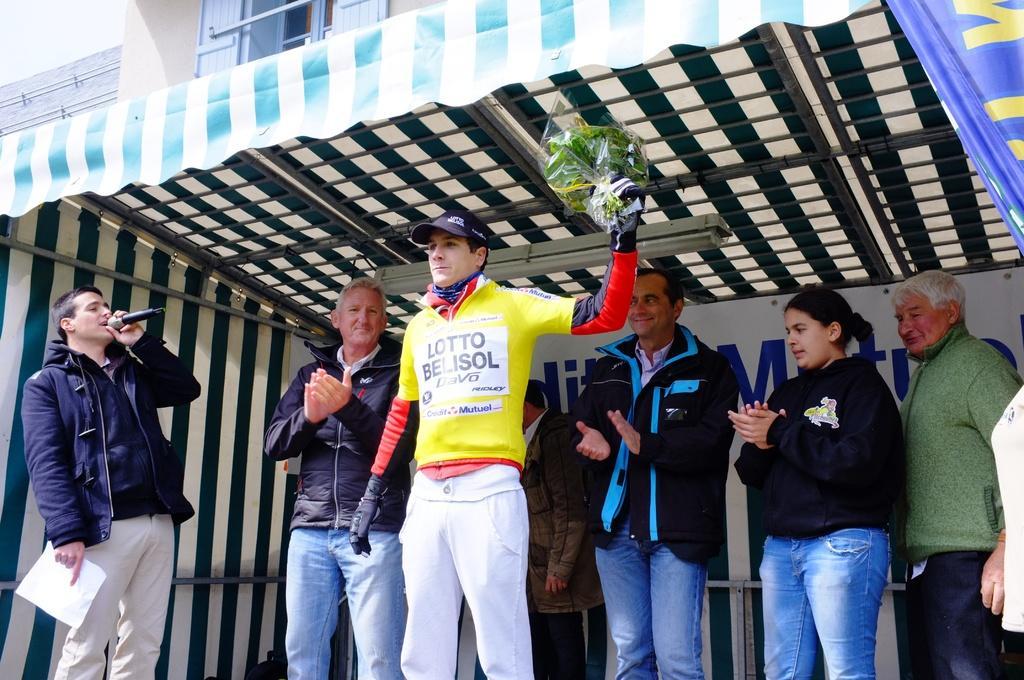Could you give a brief overview of what you see in this image? In the center of the image, we can see a man holding a bouquet and in the background, we can see a tent and there are some other people. At the top, there is a building. 